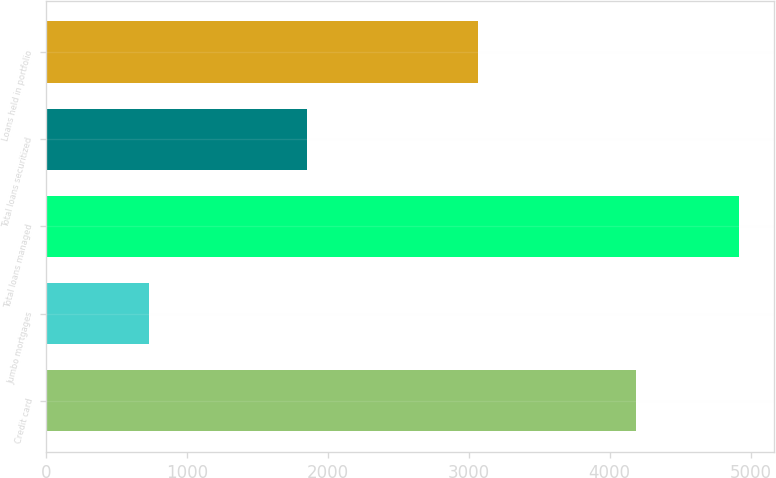Convert chart to OTSL. <chart><loc_0><loc_0><loc_500><loc_500><bar_chart><fcel>Credit card<fcel>Jumbo mortgages<fcel>Total loans managed<fcel>Total loans securitized<fcel>Loans held in portfolio<nl><fcel>4190<fcel>729<fcel>4919<fcel>1854<fcel>3062<nl></chart> 